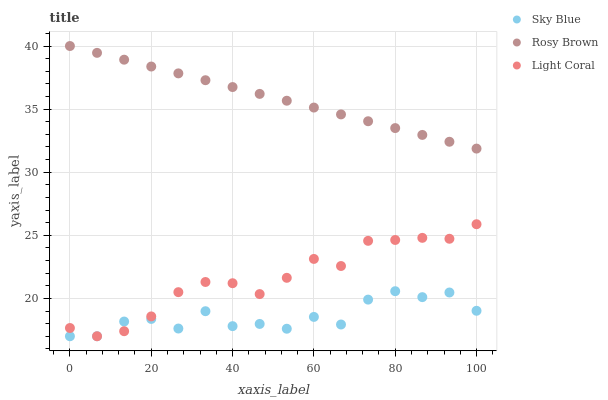Does Sky Blue have the minimum area under the curve?
Answer yes or no. Yes. Does Rosy Brown have the maximum area under the curve?
Answer yes or no. Yes. Does Rosy Brown have the minimum area under the curve?
Answer yes or no. No. Does Sky Blue have the maximum area under the curve?
Answer yes or no. No. Is Rosy Brown the smoothest?
Answer yes or no. Yes. Is Sky Blue the roughest?
Answer yes or no. Yes. Is Sky Blue the smoothest?
Answer yes or no. No. Is Rosy Brown the roughest?
Answer yes or no. No. Does Light Coral have the lowest value?
Answer yes or no. Yes. Does Rosy Brown have the lowest value?
Answer yes or no. No. Does Rosy Brown have the highest value?
Answer yes or no. Yes. Does Sky Blue have the highest value?
Answer yes or no. No. Is Light Coral less than Rosy Brown?
Answer yes or no. Yes. Is Rosy Brown greater than Light Coral?
Answer yes or no. Yes. Does Light Coral intersect Sky Blue?
Answer yes or no. Yes. Is Light Coral less than Sky Blue?
Answer yes or no. No. Is Light Coral greater than Sky Blue?
Answer yes or no. No. Does Light Coral intersect Rosy Brown?
Answer yes or no. No. 